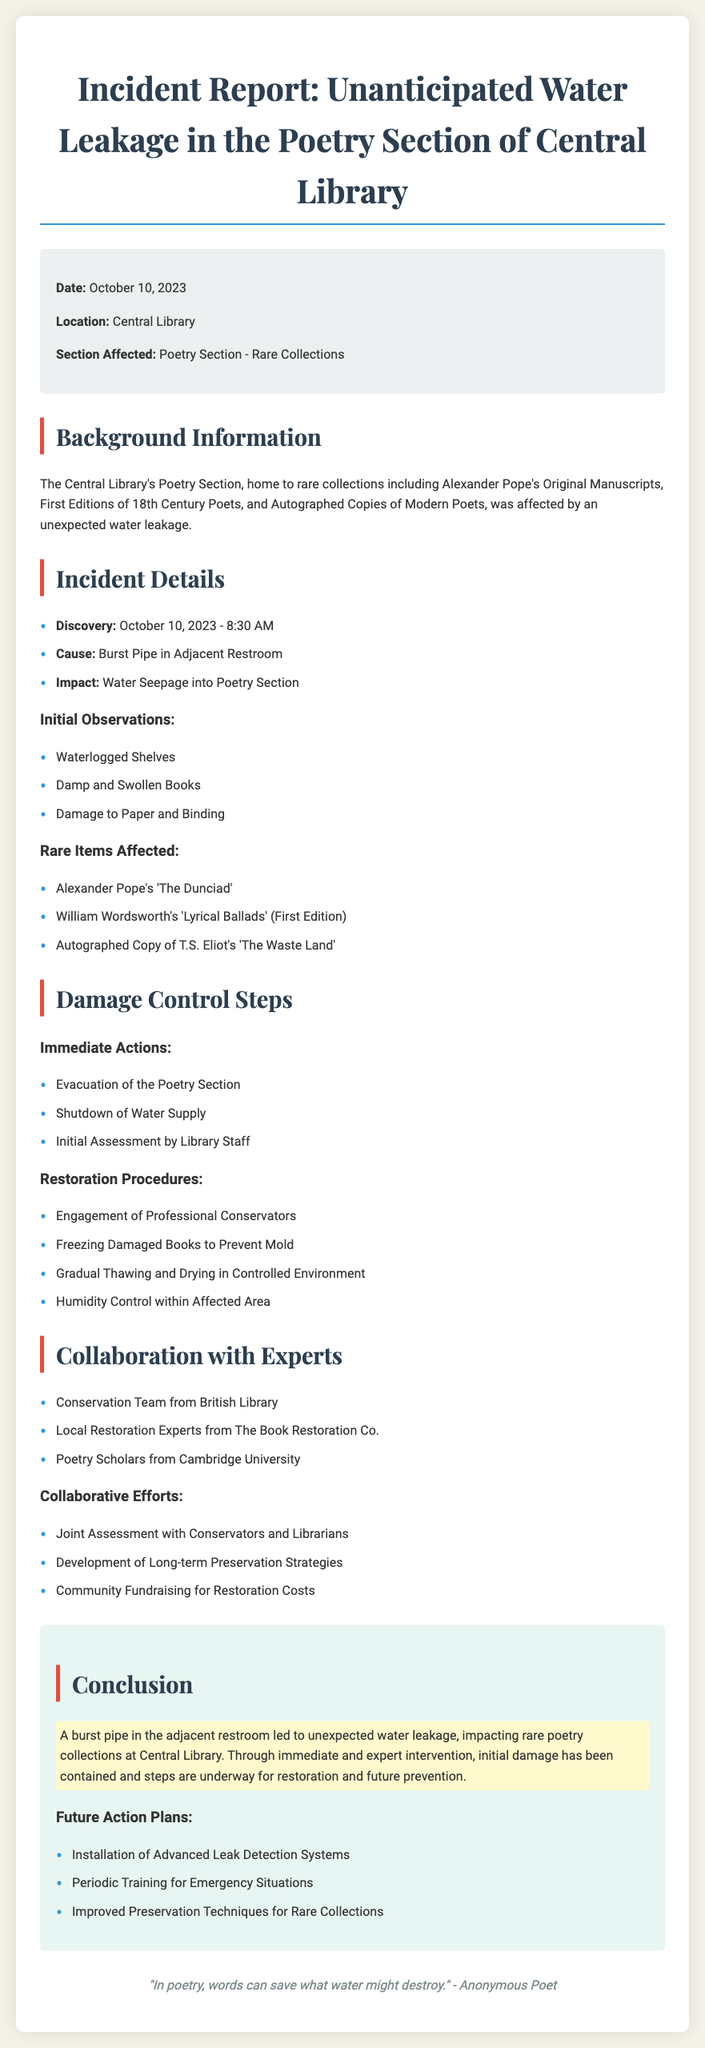What date did the incident occur? The document specifies the date of the incident in the incident details section.
Answer: October 10, 2023 What was the cause of the water leakage? The cause is mentioned in the incident details, specifying the source of the leak.
Answer: Burst Pipe in Adjacent Restroom Which rare item was affected among the collections? The document lists rare items affected, specifically mentioning the title of one.
Answer: Alexander Pope's 'The Dunciad' What immediate action was taken first after discovering the leak? The immediate actions are listed, and the first action is clearly stated.
Answer: Evacuation of the Poetry Section Who is included in the collaboration for restoration? The document lists entities collaborating for restoration efforts.
Answer: Conservation Team from British Library How many restoration procedures are mentioned? By counting the procedures listed under restoration, the answer can be derived.
Answer: Four What type of systems are planned for future action? The document specifies improvements aimed at preventing incidents in the future.
Answer: Advanced Leak Detection Systems What is the location of the incident? The location of the incident is mentioned in the document under incident details.
Answer: Central Library What is the title of the incident report? The document provides the title at the beginning, which summarizes the incident.
Answer: Incident Report: Unanticipated Water Leakage in the Poetry Section of Central Library 